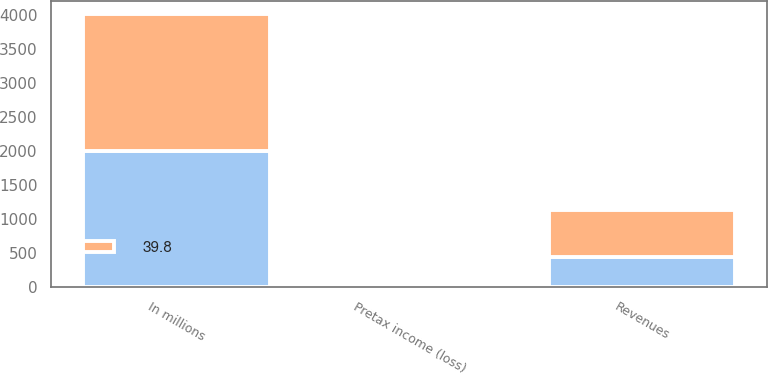<chart> <loc_0><loc_0><loc_500><loc_500><stacked_bar_chart><ecel><fcel>In millions<fcel>Revenues<fcel>Pretax income (loss)<nl><fcel>nan<fcel>2007<fcel>444.1<fcel>17<nl><fcel>39.8<fcel>2006<fcel>691.2<fcel>12<nl></chart> 